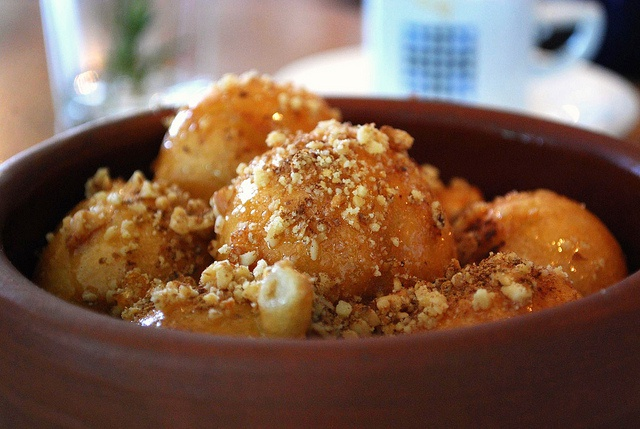Describe the objects in this image and their specific colors. I can see bowl in darkgray, maroon, black, brown, and tan tones, donut in darkgray, brown, maroon, and tan tones, donut in darkgray, brown, maroon, and orange tones, cup in darkgray and lightblue tones, and cup in darkgray, lightgray, and gray tones in this image. 